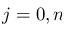Convert formula to latex. <formula><loc_0><loc_0><loc_500><loc_500>j = 0 , n</formula> 